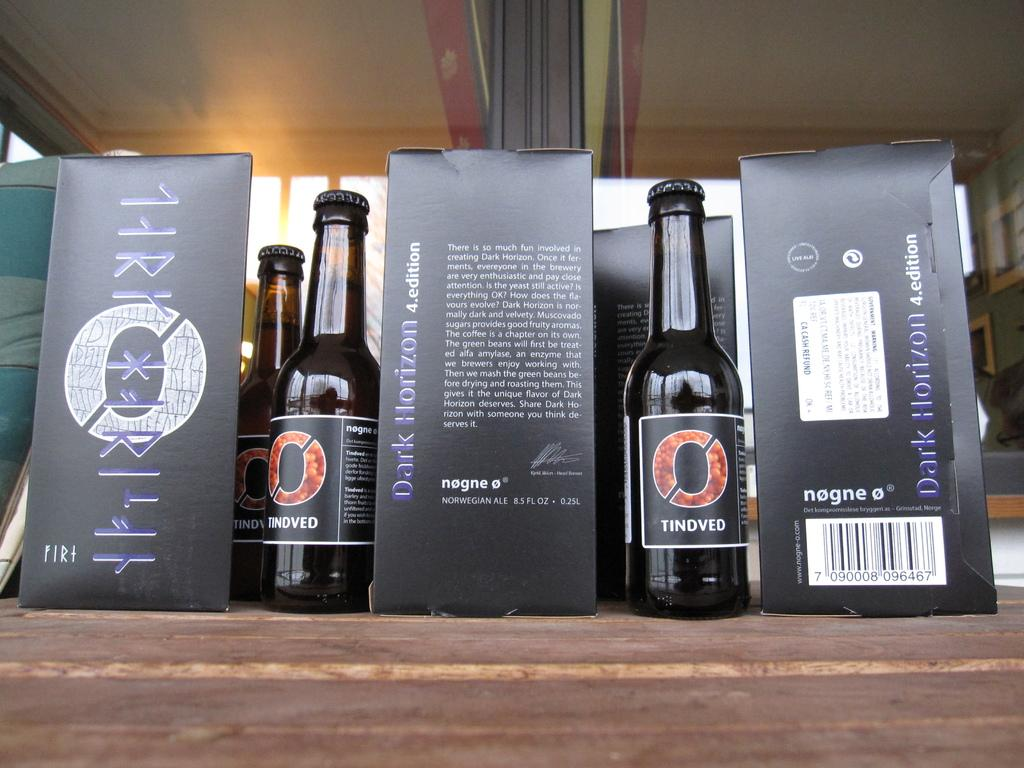<image>
Present a compact description of the photo's key features. An presentation stand showcasing bottles of Dark Horizon Norwegian Ale. 